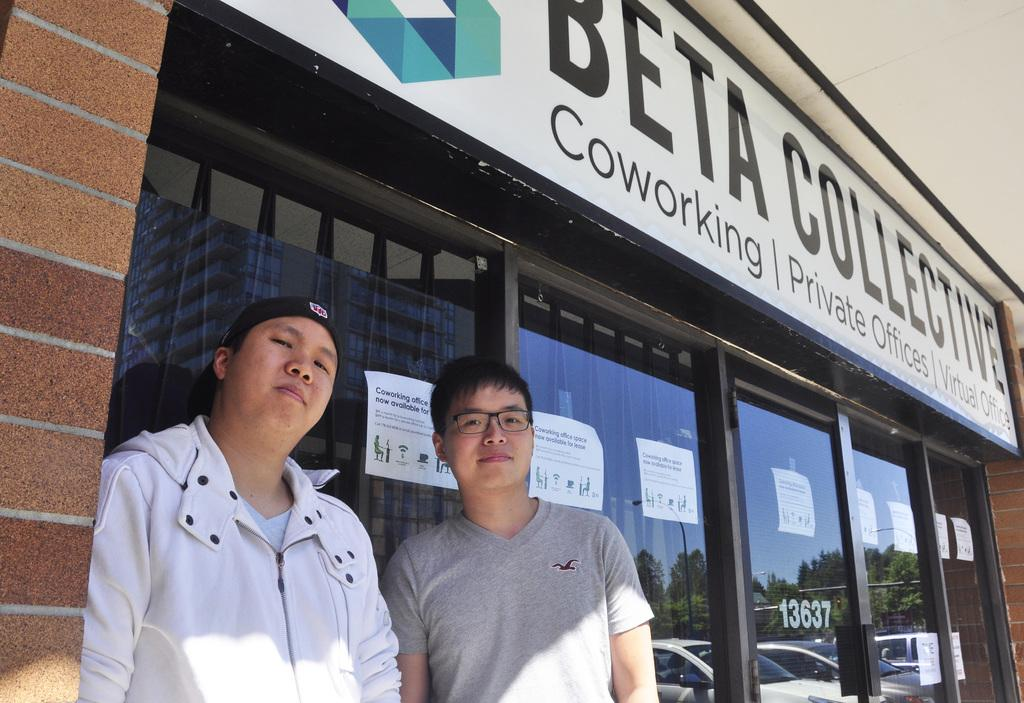How many people are present in the image? There are two people standing in the image. What can be seen in the background through the glass? Posts on glass, trees, cars, and the sky are visible through the glass in the background. What is located at the top of the image? There is a board at the top of the image. What type of trade is being conducted between the two people in the image? There is no indication of any trade being conducted between the two people in the image. Can you tell me how many fans are visible in the image? There are no fans present in the image. 